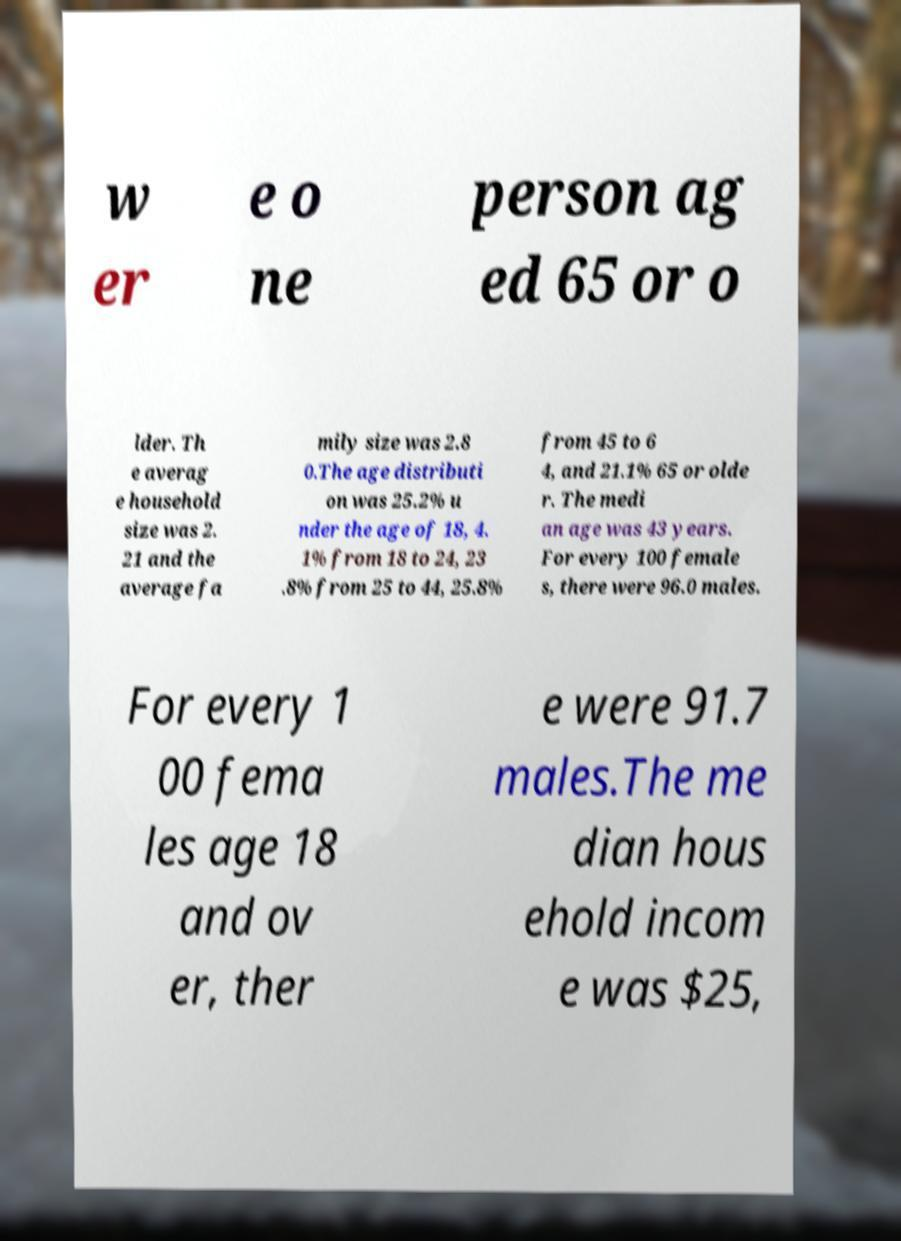For documentation purposes, I need the text within this image transcribed. Could you provide that? w er e o ne person ag ed 65 or o lder. Th e averag e household size was 2. 21 and the average fa mily size was 2.8 0.The age distributi on was 25.2% u nder the age of 18, 4. 1% from 18 to 24, 23 .8% from 25 to 44, 25.8% from 45 to 6 4, and 21.1% 65 or olde r. The medi an age was 43 years. For every 100 female s, there were 96.0 males. For every 1 00 fema les age 18 and ov er, ther e were 91.7 males.The me dian hous ehold incom e was $25, 